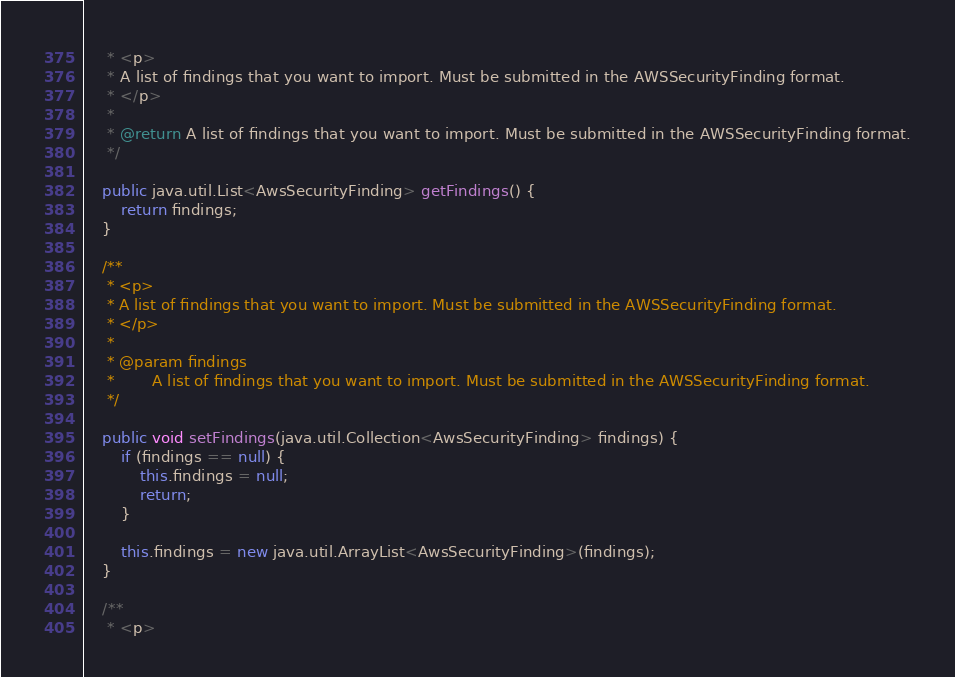Convert code to text. <code><loc_0><loc_0><loc_500><loc_500><_Java_>     * <p>
     * A list of findings that you want to import. Must be submitted in the AWSSecurityFinding format.
     * </p>
     * 
     * @return A list of findings that you want to import. Must be submitted in the AWSSecurityFinding format.
     */

    public java.util.List<AwsSecurityFinding> getFindings() {
        return findings;
    }

    /**
     * <p>
     * A list of findings that you want to import. Must be submitted in the AWSSecurityFinding format.
     * </p>
     * 
     * @param findings
     *        A list of findings that you want to import. Must be submitted in the AWSSecurityFinding format.
     */

    public void setFindings(java.util.Collection<AwsSecurityFinding> findings) {
        if (findings == null) {
            this.findings = null;
            return;
        }

        this.findings = new java.util.ArrayList<AwsSecurityFinding>(findings);
    }

    /**
     * <p></code> 